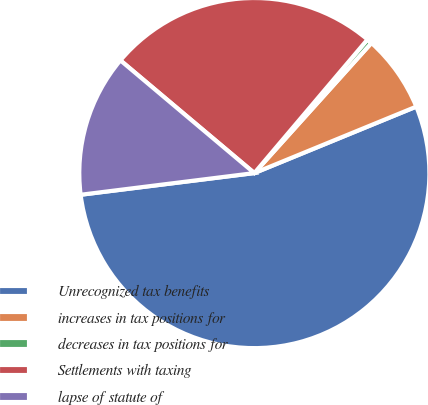Convert chart to OTSL. <chart><loc_0><loc_0><loc_500><loc_500><pie_chart><fcel>Unrecognized tax benefits<fcel>increases in tax positions for<fcel>decreases in tax positions for<fcel>Settlements with taxing<fcel>lapse of statute of<nl><fcel>54.22%<fcel>7.14%<fcel>0.48%<fcel>25.05%<fcel>13.11%<nl></chart> 